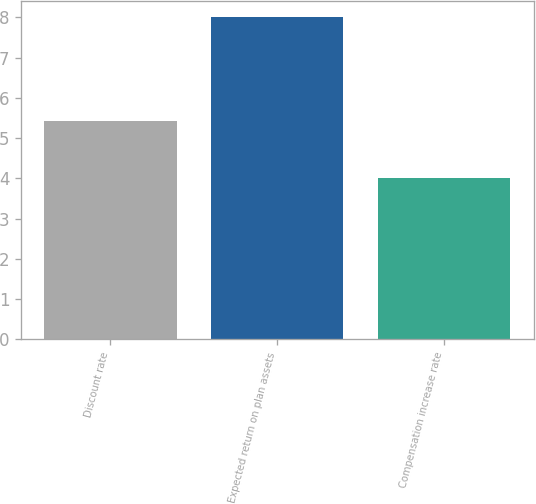Convert chart to OTSL. <chart><loc_0><loc_0><loc_500><loc_500><bar_chart><fcel>Discount rate<fcel>Expected return on plan assets<fcel>Compensation increase rate<nl><fcel>5.42<fcel>8<fcel>4<nl></chart> 